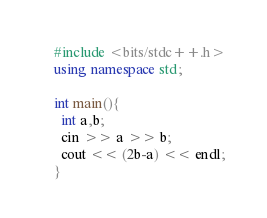<code> <loc_0><loc_0><loc_500><loc_500><_C++_>#include <bits/stdc++.h>
using namespace std;

int main(){
  int a,b;
  cin >> a >> b;
  cout << (2b-a) << endl;
}
</code> 